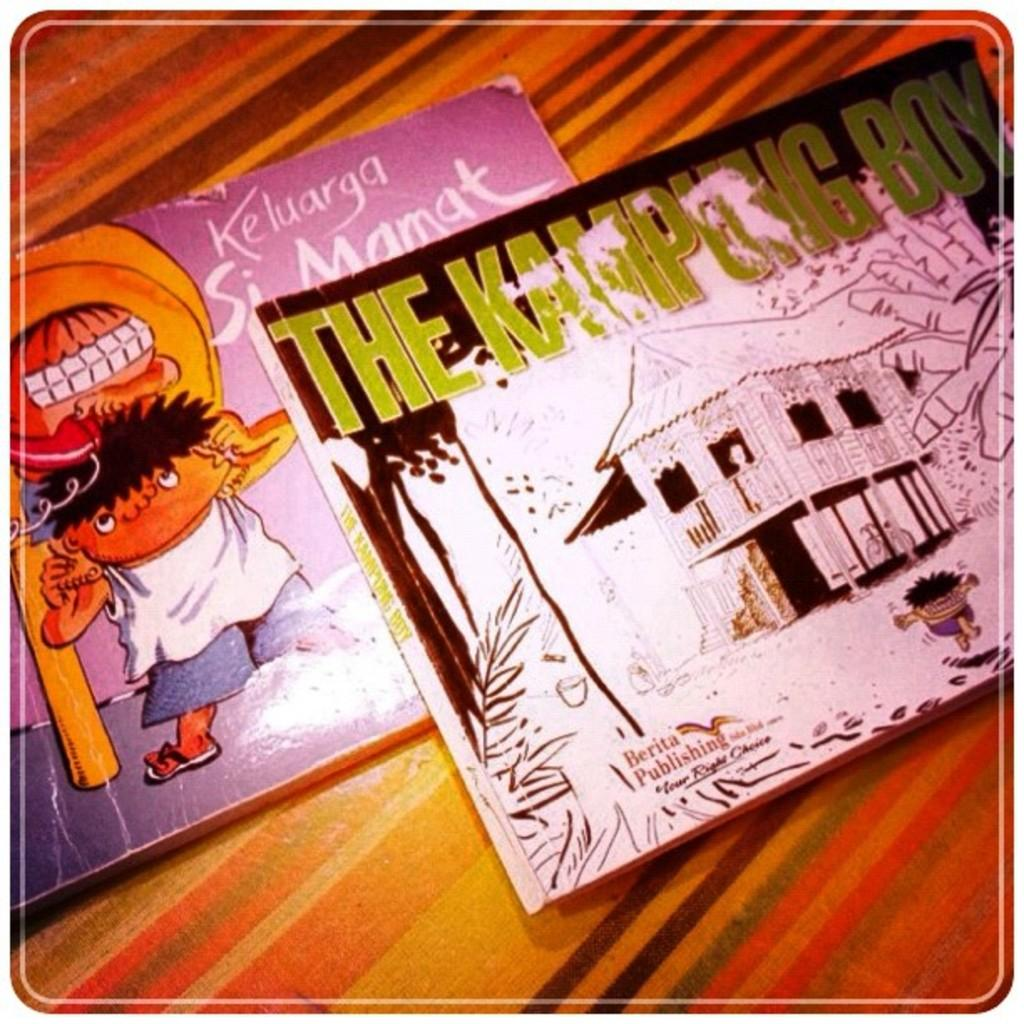<image>
Render a clear and concise summary of the photo. The book with the green writing is called The Kampung Boy 